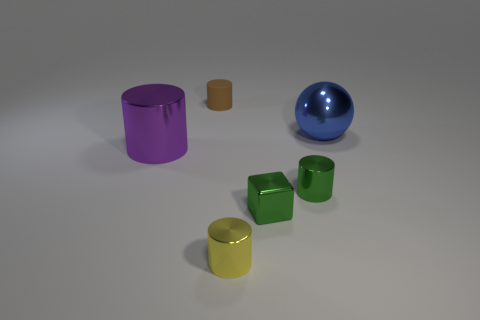Add 4 large shiny balls. How many objects exist? 10 Subtract all cylinders. How many objects are left? 2 Add 4 tiny metallic things. How many tiny metallic things are left? 7 Add 2 brown rubber objects. How many brown rubber objects exist? 3 Subtract 0 purple blocks. How many objects are left? 6 Subtract all small red metallic cylinders. Subtract all tiny metal blocks. How many objects are left? 5 